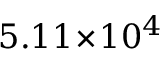<formula> <loc_0><loc_0><loc_500><loc_500>5 . 1 1 \, \times \, 1 0 ^ { 4 }</formula> 